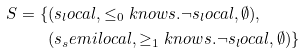<formula> <loc_0><loc_0><loc_500><loc_500>S = \{ & ( s _ { l } o c a l , \leq _ { 0 } k n o w s . \neg s _ { l } o c a l , \emptyset ) , \\ & ( s _ { s } e m i l o c a l , \geq _ { 1 } k n o w s . \neg s _ { l } o c a l , \emptyset ) \}</formula> 